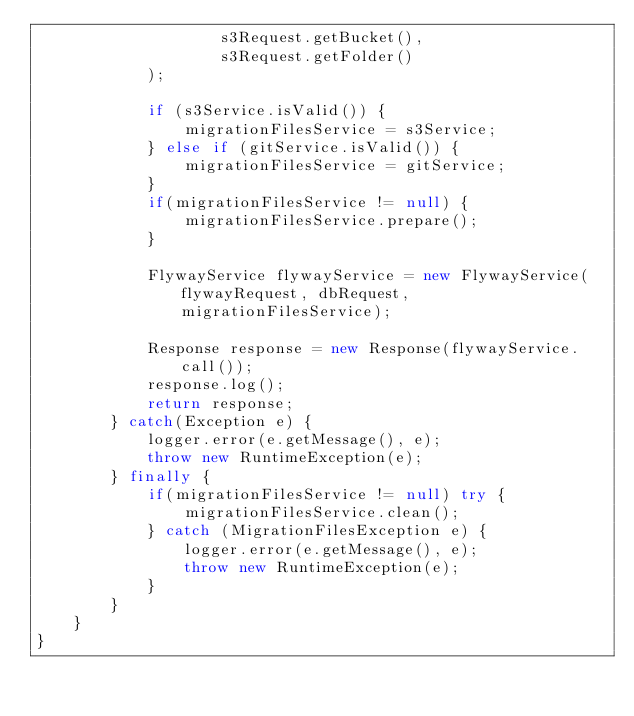<code> <loc_0><loc_0><loc_500><loc_500><_Java_>                    s3Request.getBucket(),
                    s3Request.getFolder()
            );

            if (s3Service.isValid()) {
                migrationFilesService = s3Service;
            } else if (gitService.isValid()) {
                migrationFilesService = gitService;
            }
            if(migrationFilesService != null) {
                migrationFilesService.prepare();
            }

            FlywayService flywayService = new FlywayService(flywayRequest, dbRequest, migrationFilesService);

            Response response = new Response(flywayService.call());
            response.log();
            return response;
        } catch(Exception e) {
            logger.error(e.getMessage(), e);
            throw new RuntimeException(e);
        } finally {
            if(migrationFilesService != null) try {
                migrationFilesService.clean();
            } catch (MigrationFilesException e) {
                logger.error(e.getMessage(), e);
                throw new RuntimeException(e);
            }
        }
    }
}
</code> 